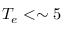<formula> <loc_0><loc_0><loc_500><loc_500>T _ { e } < \sim 5</formula> 